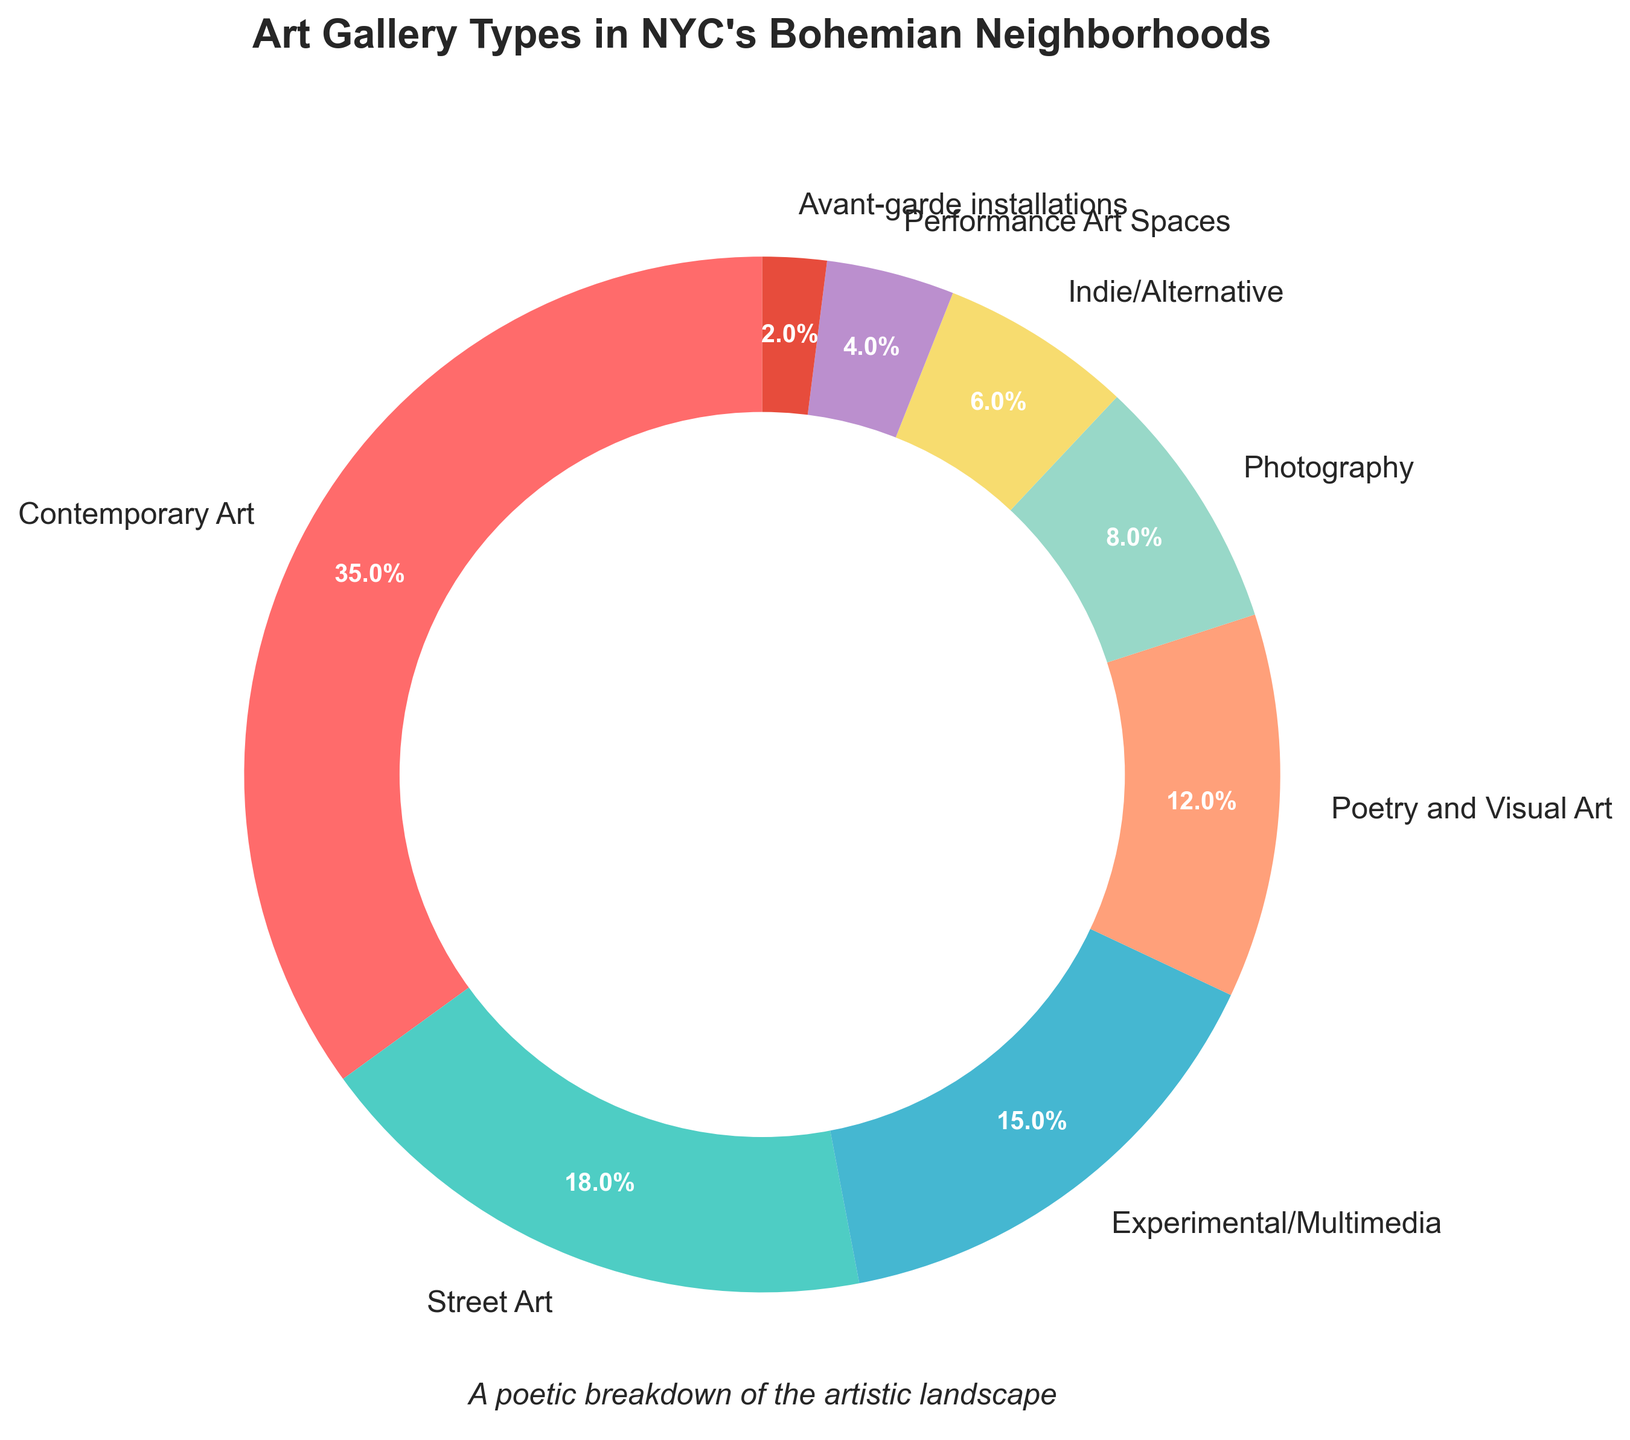Which gallery type occupies the largest percentage of art galleries in NYC's bohemian neighborhoods? The chart shows that Contemporary Art has the largest slice, visually confirming it as the largest percentage.
Answer: Contemporary Art Which type of gallery holds a higher percentage: Street Art or Photography? By comparing the slices, Street Art's percentage is larger than Photography's.
Answer: Street Art Are Poetry and Visual Art galleries more numerous than Indie/Alternative galleries? Poetry and Visual Art galleries have a 12% slice, while Indie/Alternative galleries have a 6% slice. 12% is larger than 6%.
Answer: Yes What's the combined percentage of Experimental/Multimedia and Performance Art Spaces galleries? Add the percentages for Experimental/Multimedia (15%) and Performance Art Spaces (4%). 15% + 4% = 19%
Answer: 19% What is the difference in percentage between Contemporary Art and Street Art galleries? Subtract the percentage of Street Art (18%) from Contemporary Art (35%). 35% - 18% = 17%
Answer: 17% How much greater is the percentage of Contemporary Art galleries compared to Avant-garde installations? Subtract Avant-garde installations' percentage (2%) from Contemporary Art's (35%). 35% - 2% = 33%
Answer: 33% If you combine the percentages of galleries dedicated to Poetry and Visual Art, and Indie/Alternative, how does it compare to the percentage of Street Art galleries? Add Poetry and Visual Art (12%) and Indie/Alternative (6%), getting 18%. Compare with Street Art (18%). 12% + 6% equals 18%, which is equal to Street Art's percentage.
Answer: Equal Which has the smaller percentage: Experimental/Multimedia or Photography galleries? Compare the slices: Experimental/Multimedia is 15%, and Photography is 8%. Photography is smaller.
Answer: Photography Compare the visual areas of Street Art and Indie/Alternative galleries. Which is larger? Street Art has a larger visual slice (18%) compared to Indie/Alternative (6%).
Answer: Street Art Originally holding separate entities, if Photography and Performance Art Spaces merged, what percentage would they collectively hold? Add Photography (8%) and Performance Art Spaces (4%). 8% + 4% = 12%
Answer: 12% 